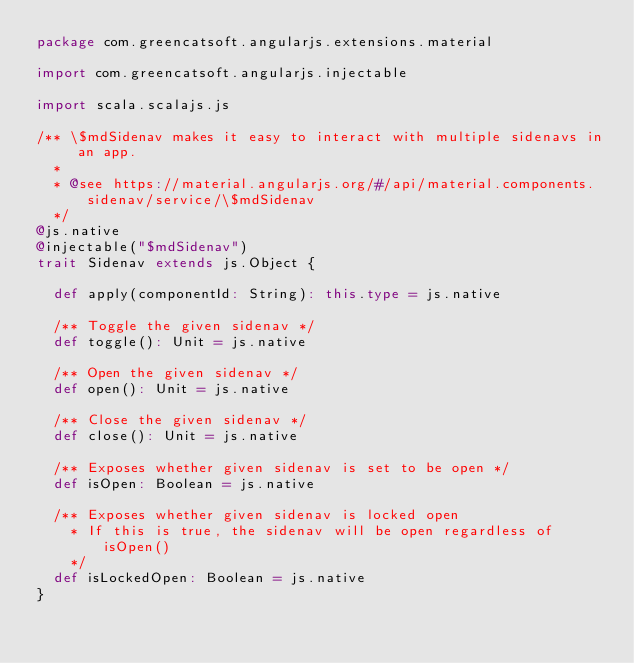Convert code to text. <code><loc_0><loc_0><loc_500><loc_500><_Scala_>package com.greencatsoft.angularjs.extensions.material

import com.greencatsoft.angularjs.injectable

import scala.scalajs.js

/** \$mdSidenav makes it easy to interact with multiple sidenavs in an app.
  *
  * @see https://material.angularjs.org/#/api/material.components.sidenav/service/\$mdSidenav
  */
@js.native
@injectable("$mdSidenav")
trait Sidenav extends js.Object {

  def apply(componentId: String): this.type = js.native

  /** Toggle the given sidenav */
  def toggle(): Unit = js.native

  /** Open the given sidenav */
  def open(): Unit = js.native

  /** Close the given sidenav */
  def close(): Unit = js.native

  /** Exposes whether given sidenav is set to be open */
  def isOpen: Boolean = js.native

  /** Exposes whether given sidenav is locked open
    * If this is true, the sidenav will be open regardless of isOpen()
    */
  def isLockedOpen: Boolean = js.native
}</code> 